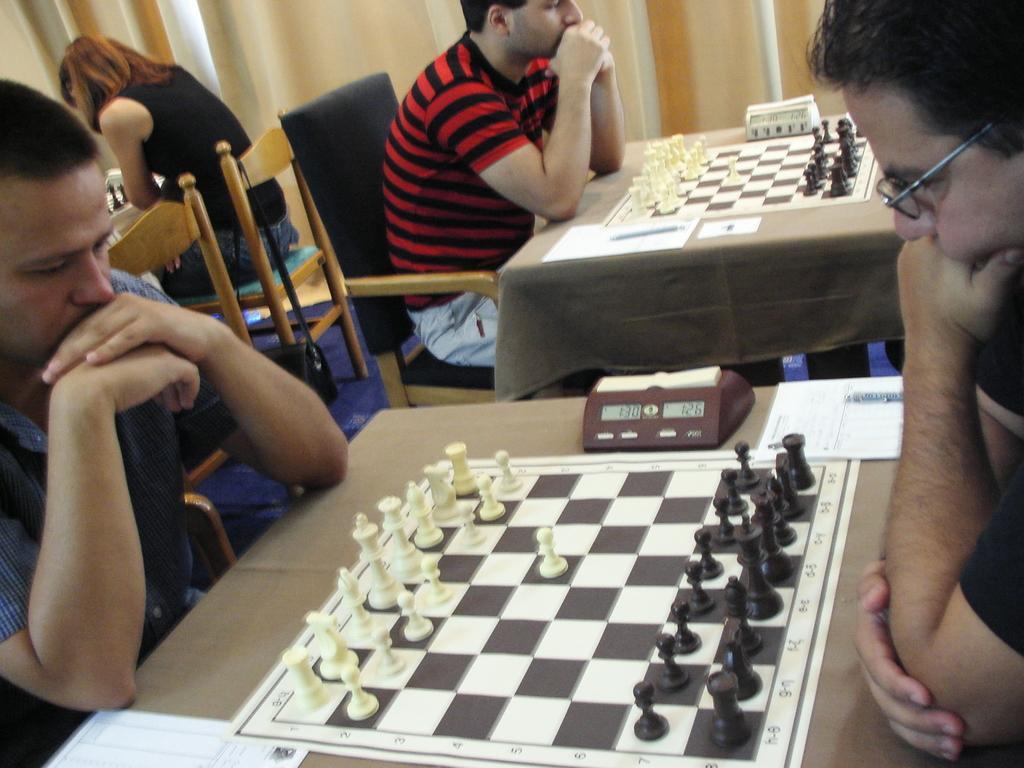In one or two sentences, can you explain what this image depicts? Here we can see that a person sitting on the chair and playing chess, and there are some objects on the table, and in front a person is sitting, and at side a man is sitting on the chair, and here is the pole, and at back a woman is sitting, and here is the floor. 